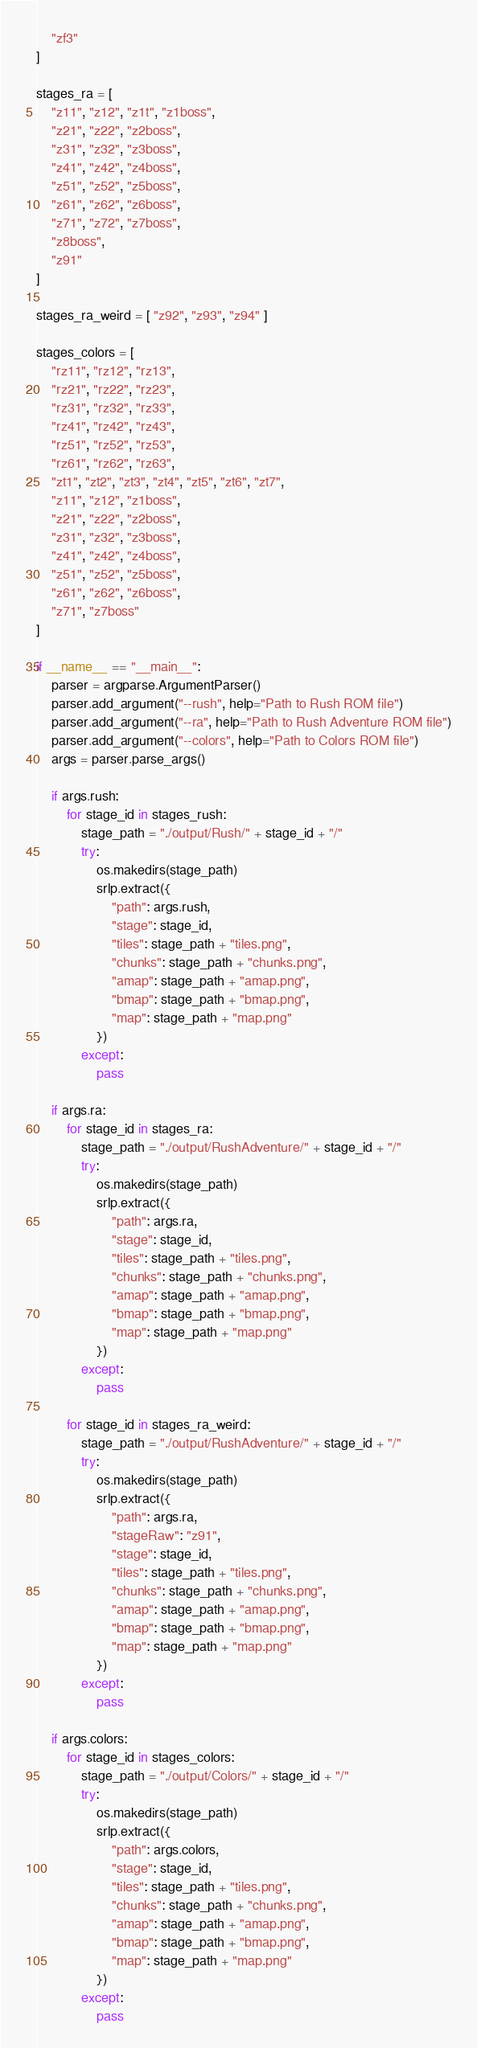<code> <loc_0><loc_0><loc_500><loc_500><_Python_>	"zf3"
]

stages_ra = [
	"z11", "z12", "z1t", "z1boss",
	"z21", "z22", "z2boss",
	"z31", "z32", "z3boss",
	"z41", "z42", "z4boss",
	"z51", "z52", "z5boss",
	"z61", "z62", "z6boss",
	"z71", "z72", "z7boss",
	"z8boss", 
	"z91"
]

stages_ra_weird = [ "z92", "z93", "z94" ]

stages_colors = [
	"rz11", "rz12", "rz13",
	"rz21", "rz22", "rz23",
	"rz31", "rz32", "rz33",
	"rz41", "rz42", "rz43",
	"rz51", "rz52", "rz53",
	"rz61", "rz62", "rz63",
	"zt1", "zt2", "zt3", "zt4", "zt5", "zt6", "zt7",
	"z11", "z12", "z1boss",
	"z21", "z22", "z2boss",
	"z31", "z32", "z3boss",
	"z41", "z42", "z4boss",
	"z51", "z52", "z5boss",
	"z61", "z62", "z6boss",
	"z71", "z7boss"
]

if __name__ == "__main__":
	parser = argparse.ArgumentParser()
	parser.add_argument("--rush", help="Path to Rush ROM file")
	parser.add_argument("--ra", help="Path to Rush Adventure ROM file")
	parser.add_argument("--colors", help="Path to Colors ROM file")
	args = parser.parse_args()

	if args.rush:
		for stage_id in stages_rush:
			stage_path = "./output/Rush/" + stage_id + "/"
			try:
				os.makedirs(stage_path)
				srlp.extract({
					"path": args.rush,
					"stage": stage_id,
					"tiles": stage_path + "tiles.png",
					"chunks": stage_path + "chunks.png",
					"amap": stage_path + "amap.png",
					"bmap": stage_path + "bmap.png",
					"map": stage_path + "map.png"
				})
			except:
				pass

	if args.ra:
		for stage_id in stages_ra:
			stage_path = "./output/RushAdventure/" + stage_id + "/"
			try:
				os.makedirs(stage_path)
				srlp.extract({
					"path": args.ra,
					"stage": stage_id,
					"tiles": stage_path + "tiles.png",
					"chunks": stage_path + "chunks.png",
					"amap": stage_path + "amap.png",
					"bmap": stage_path + "bmap.png",
					"map": stage_path + "map.png"
				})
			except:
				pass

		for stage_id in stages_ra_weird:
			stage_path = "./output/RushAdventure/" + stage_id + "/"
			try:
				os.makedirs(stage_path)
				srlp.extract({
					"path": args.ra,
					"stageRaw": "z91",
					"stage": stage_id,
					"tiles": stage_path + "tiles.png",
					"chunks": stage_path + "chunks.png",
					"amap": stage_path + "amap.png",
					"bmap": stage_path + "bmap.png",
					"map": stage_path + "map.png"
				})
			except:
				pass

	if args.colors:
		for stage_id in stages_colors:
			stage_path = "./output/Colors/" + stage_id + "/"
			try:
				os.makedirs(stage_path)
				srlp.extract({
					"path": args.colors,
					"stage": stage_id,
					"tiles": stage_path + "tiles.png",
					"chunks": stage_path + "chunks.png",
					"amap": stage_path + "amap.png",
					"bmap": stage_path + "bmap.png",
					"map": stage_path + "map.png"
				})
			except:
				pass</code> 